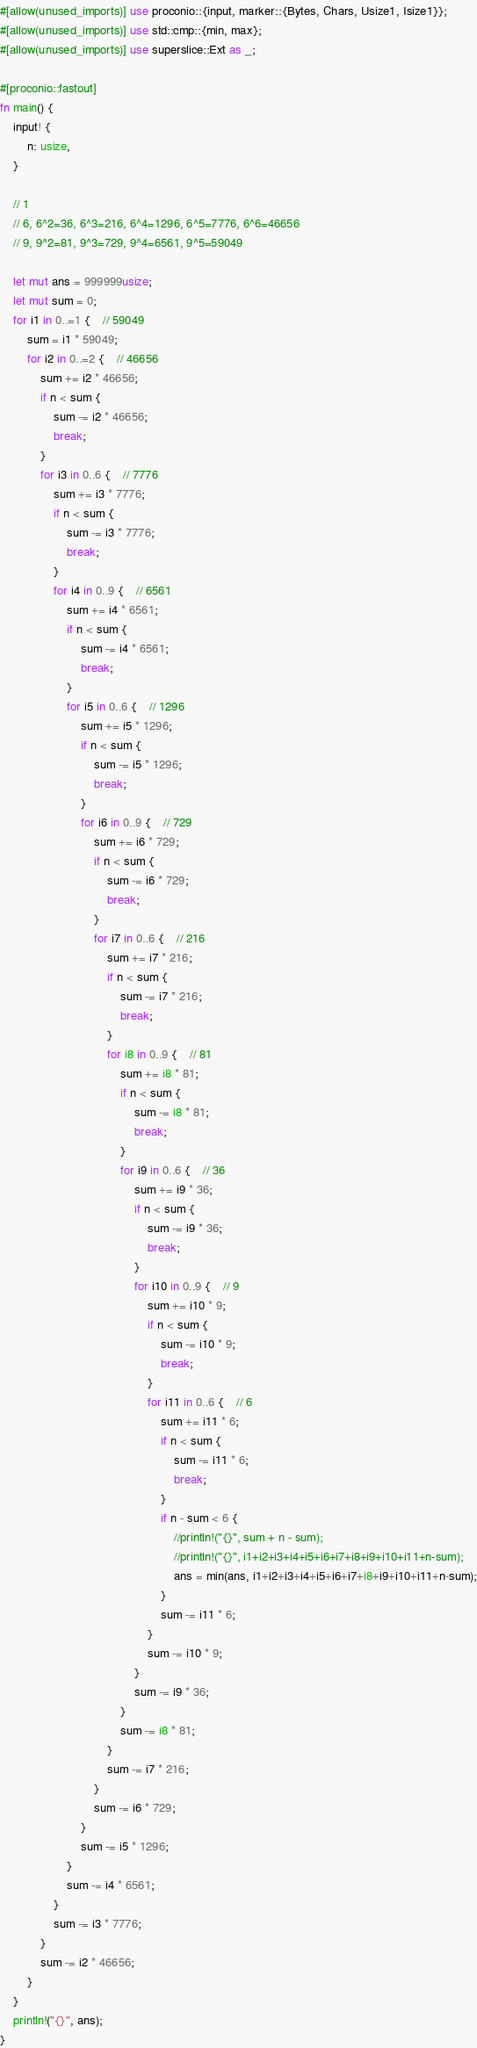<code> <loc_0><loc_0><loc_500><loc_500><_Rust_>#[allow(unused_imports)] use proconio::{input, marker::{Bytes, Chars, Usize1, Isize1}};
#[allow(unused_imports)] use std::cmp::{min, max};
#[allow(unused_imports)] use superslice::Ext as _;

#[proconio::fastout]
fn main() {
	input! {
		n: usize,
	}

	// 1
	// 6, 6^2=36, 6^3=216, 6^4=1296, 6^5=7776, 6^6=46656 
	// 9, 9^2=81, 9^3=729, 9^4=6561, 9^5=59049

	let mut ans = 999999usize;
	let mut sum = 0;
	for i1 in 0..=1 {	// 59049
		sum = i1 * 59049;
		for i2 in 0..=2 {	// 46656
			sum += i2 * 46656;
			if n < sum {
				sum -= i2 * 46656;
				break;
			}
			for i3 in 0..6 {	// 7776
				sum += i3 * 7776;
				if n < sum {
					sum -= i3 * 7776;
					break;
				}
				for i4 in 0..9 {	// 6561
					sum += i4 * 6561;
					if n < sum {
						sum -= i4 * 6561;
						break;
					}
					for i5 in 0..6 {	// 1296
						sum += i5 * 1296;
						if n < sum {
							sum -= i5 * 1296;
							break;
						}
						for i6 in 0..9 {	// 729
							sum += i6 * 729;
							if n < sum {
								sum -= i6 * 729;
								break;
							}
							for i7 in 0..6 {	// 216
								sum += i7 * 216;
								if n < sum {
									sum -= i7 * 216;
									break;
								}
								for i8 in 0..9 {	// 81
									sum += i8 * 81;
									if n < sum {
										sum -= i8 * 81;
										break;
									}
									for i9 in 0..6 {	// 36
										sum += i9 * 36;
										if n < sum {
											sum -= i9 * 36;
											break;
										}
										for i10 in 0..9 {	// 9
											sum += i10 * 9;
											if n < sum {
												sum -= i10 * 9;
												break;
											}
											for i11 in 0..6 {	// 6
												sum += i11 * 6;
												if n < sum {
													sum -= i11 * 6;
													break;
												}
												if n - sum < 6 {
													//println!("{}", sum + n - sum);
													//println!("{}", i1+i2+i3+i4+i5+i6+i7+i8+i9+i10+i11+n-sum);
													ans = min(ans, i1+i2+i3+i4+i5+i6+i7+i8+i9+i10+i11+n-sum);
												}
												sum -= i11 * 6;	
											}
											sum -= i10 * 9;
										}
										sum -= i9 * 36;
									}
									sum -= i8 * 81;
								}
								sum -= i7 * 216;
							}
							sum -= i6 * 729;
						}
						sum -= i5 * 1296;
					}
					sum -= i4 * 6561;
				}
				sum -= i3 * 7776;
			}
			sum -= i2 * 46656;
		}
	}
	println!("{}", ans);
}
</code> 